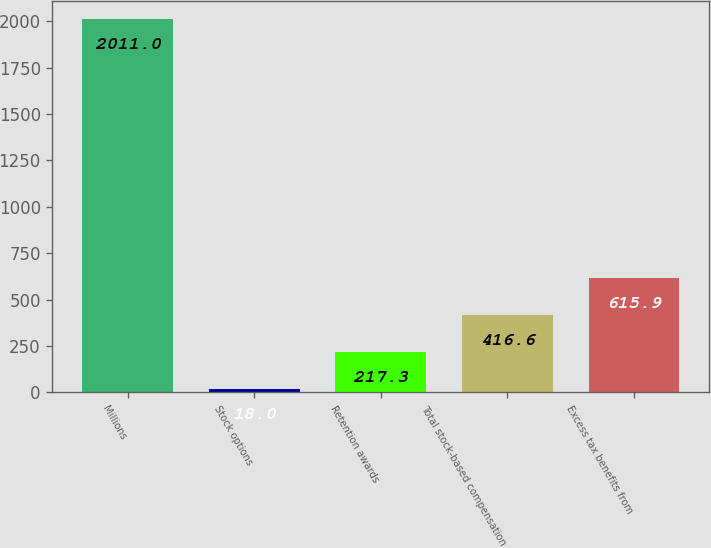Convert chart to OTSL. <chart><loc_0><loc_0><loc_500><loc_500><bar_chart><fcel>Millions<fcel>Stock options<fcel>Retention awards<fcel>Total stock-based compensation<fcel>Excess tax benefits from<nl><fcel>2011<fcel>18<fcel>217.3<fcel>416.6<fcel>615.9<nl></chart> 